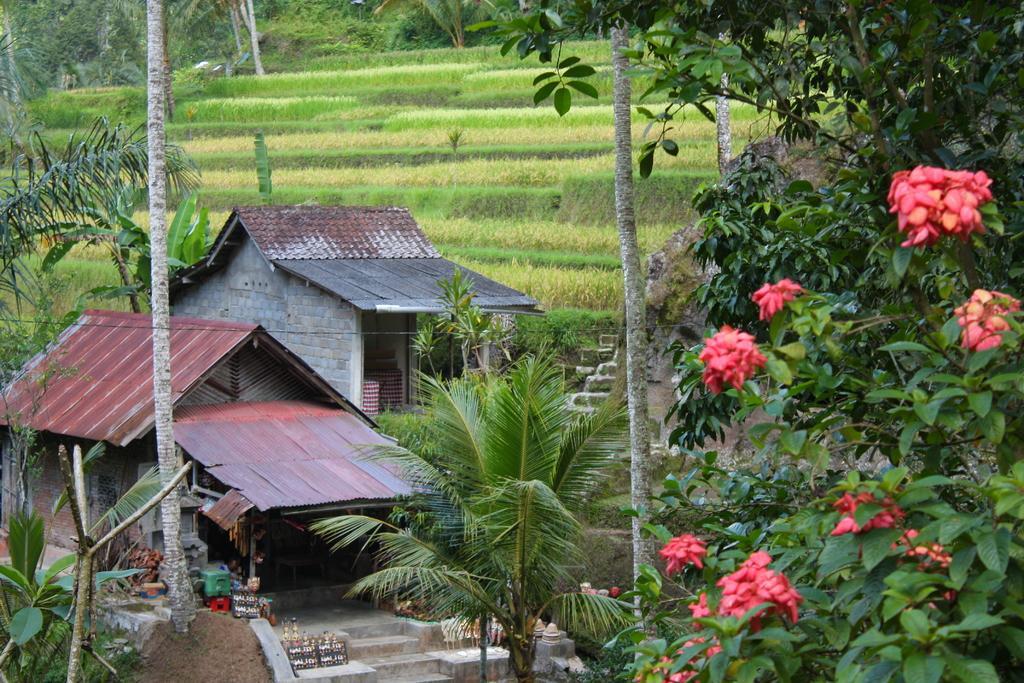Could you give a brief overview of what you see in this image? In this image in the center there are tents. In the front there is flower and there are trees. In the background there is grass on the ground and there are trees. 